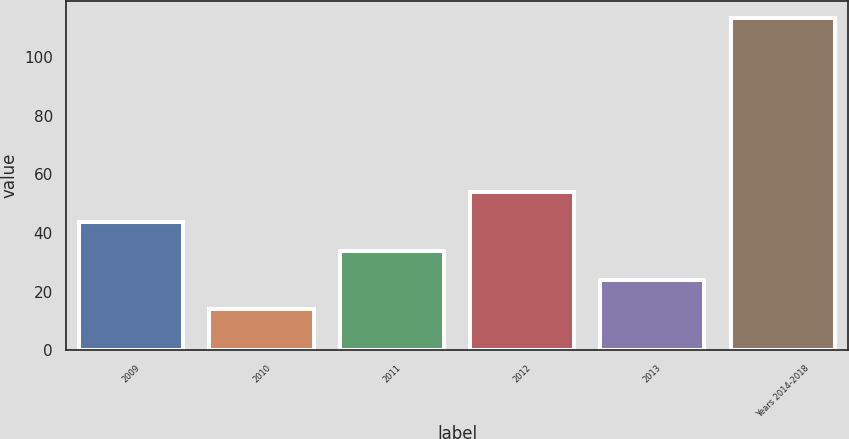Convert chart. <chart><loc_0><loc_0><loc_500><loc_500><bar_chart><fcel>2009<fcel>2010<fcel>2011<fcel>2012<fcel>2013<fcel>Years 2014-2018<nl><fcel>43.89<fcel>14.1<fcel>33.96<fcel>53.82<fcel>24.03<fcel>113.4<nl></chart> 